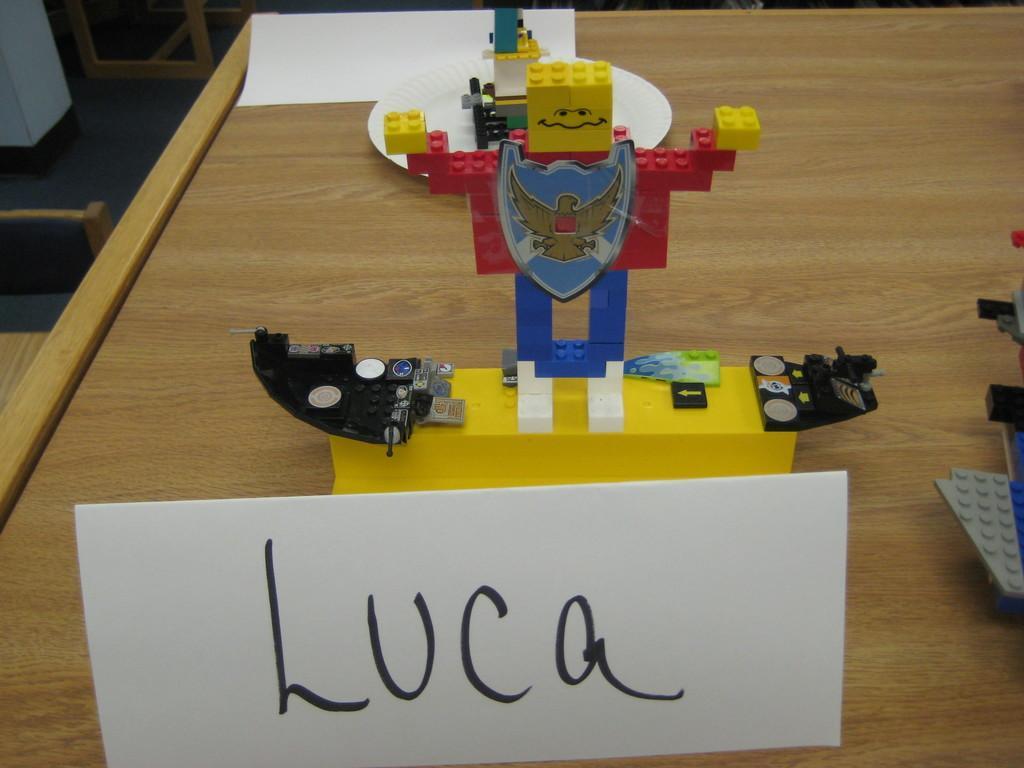Could you give a brief overview of what you see in this image? In the center of the image we can see a toy made with legos and placed on the table. 